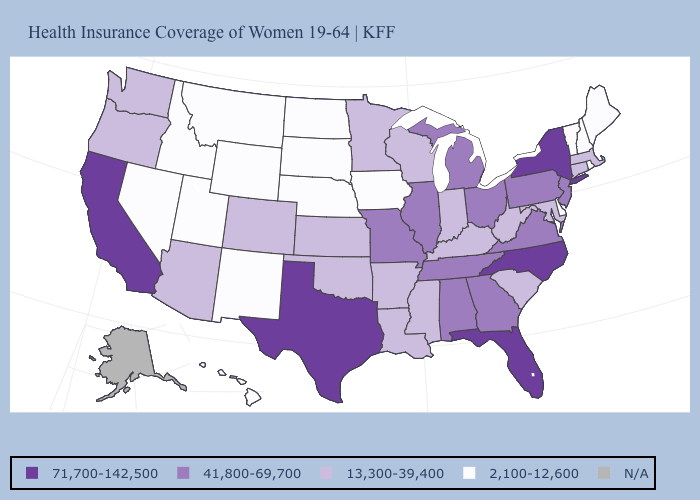Name the states that have a value in the range 2,100-12,600?
Short answer required. Delaware, Hawaii, Idaho, Iowa, Maine, Montana, Nebraska, Nevada, New Hampshire, New Mexico, North Dakota, Rhode Island, South Dakota, Utah, Vermont, Wyoming. Does Nebraska have the lowest value in the USA?
Write a very short answer. Yes. What is the lowest value in states that border Arizona?
Concise answer only. 2,100-12,600. What is the value of Iowa?
Concise answer only. 2,100-12,600. What is the lowest value in the USA?
Quick response, please. 2,100-12,600. Is the legend a continuous bar?
Concise answer only. No. How many symbols are there in the legend?
Give a very brief answer. 5. Does South Dakota have the highest value in the MidWest?
Give a very brief answer. No. Does the map have missing data?
Quick response, please. Yes. What is the lowest value in the South?
Short answer required. 2,100-12,600. What is the value of Idaho?
Give a very brief answer. 2,100-12,600. Which states have the lowest value in the South?
Give a very brief answer. Delaware. Name the states that have a value in the range N/A?
Write a very short answer. Alaska. 